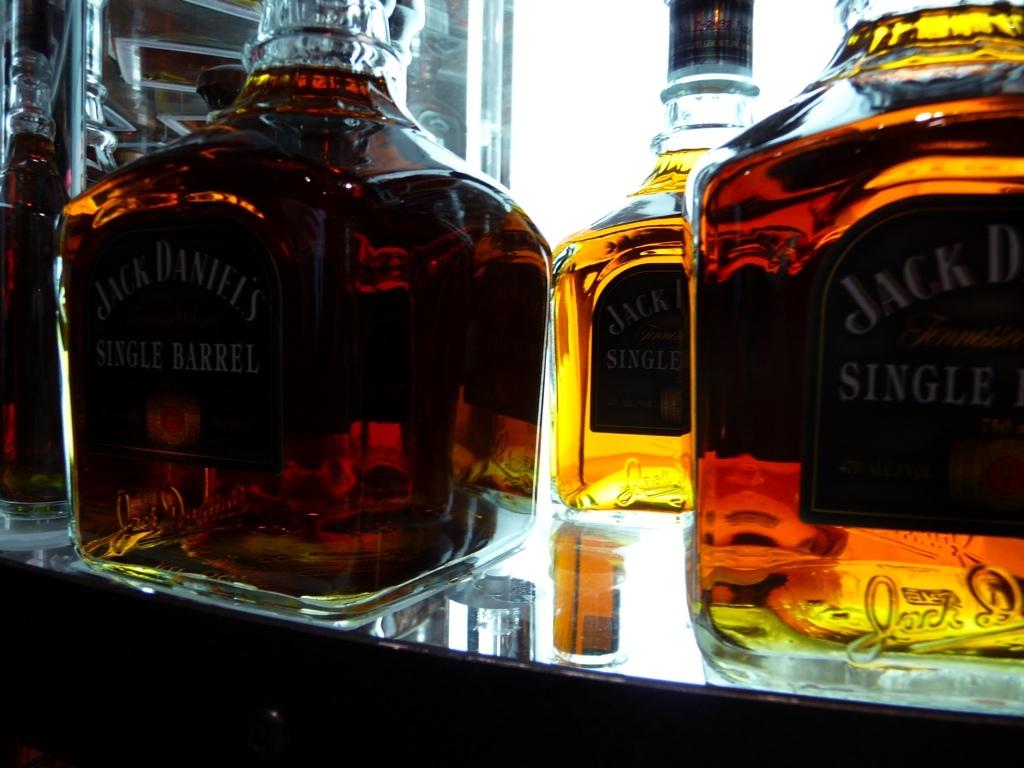What brand of whiskey is displayed?
Provide a short and direct response. Jack daniels. Is the whiskey a single barrel?
Your answer should be compact. Yes. 